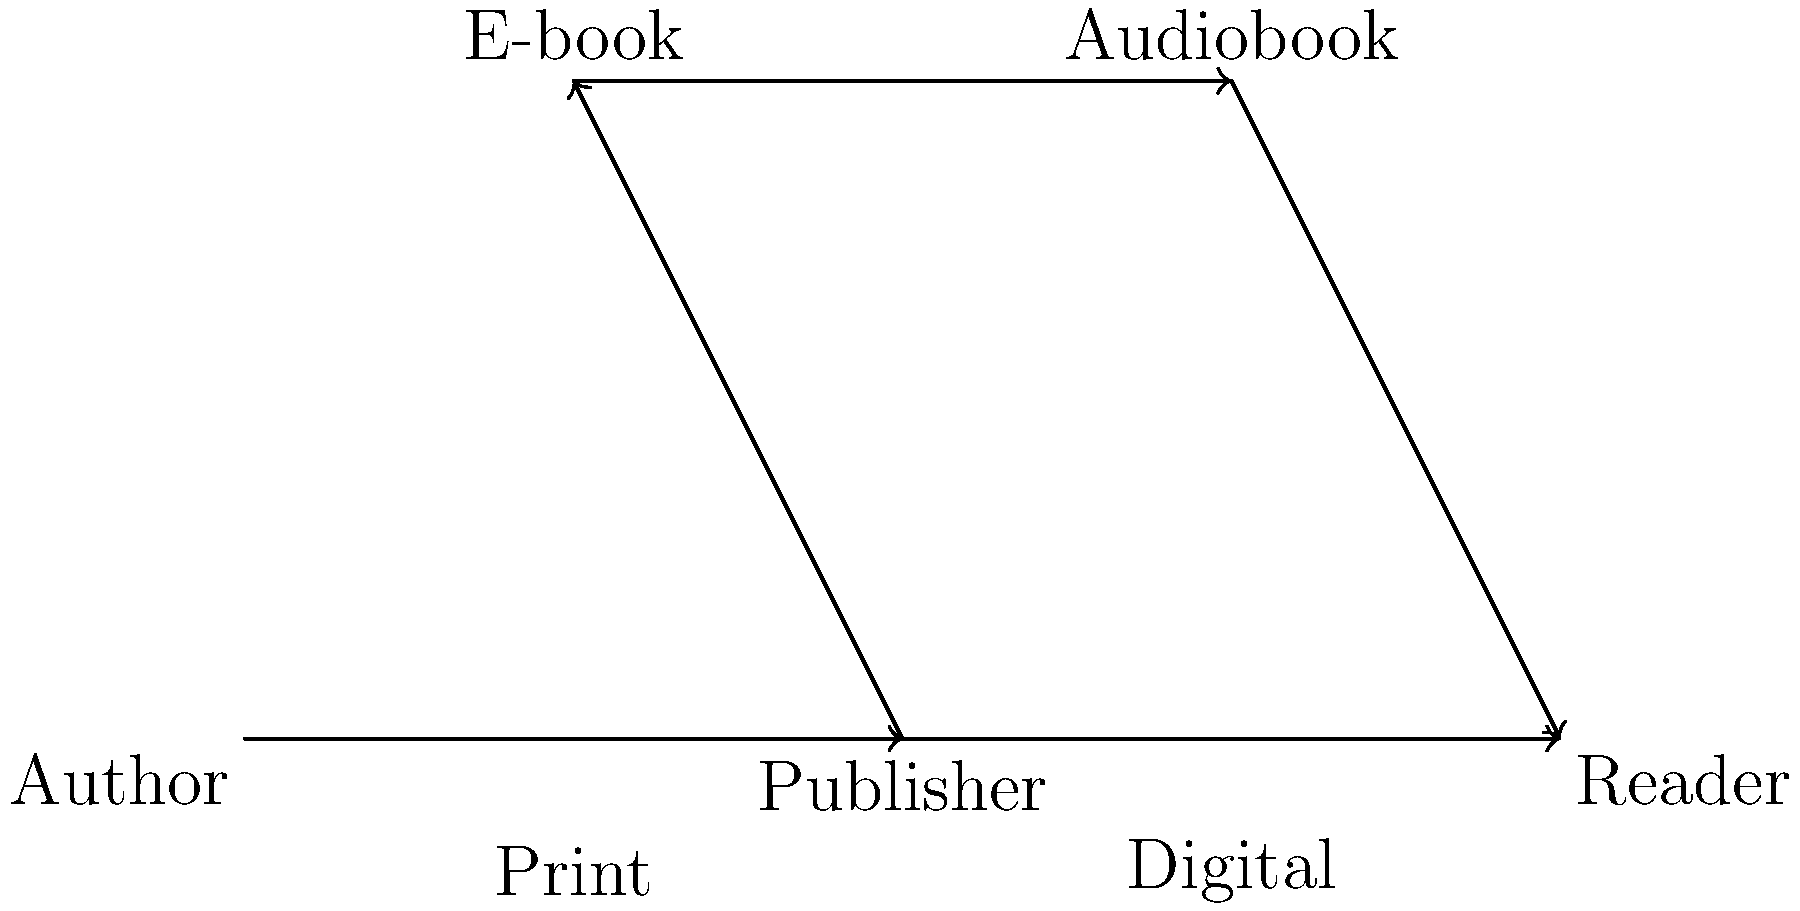In the vector representation of a book's journey from author to reader, which distribution channel typically involves the least amount of physical transportation? To answer this question, let's analyze the different distribution channels shown in the vector diagram:

1. Print books (bottom path):
   - Involves physical printing of books
   - Requires transportation from publisher to bookstores or directly to readers
   - Highest amount of physical transportation

2. E-books (upper-left path):
   - Digital files transmitted electronically
   - No physical product to transport
   - Minimal physical transportation (only for the devices used to read e-books)

3. Audiobooks (upper-right path):
   - Digital audio files transmitted electronically
   - No physical product to transport
   - Minimal physical transportation (only for the devices used to listen to audiobooks)

Comparing these channels, we can see that both e-books and audiobooks involve significantly less physical transportation than print books. However, e-books typically require less data transfer and storage space compared to audiobooks, making them slightly more efficient in terms of digital distribution.

Therefore, the distribution channel that typically involves the least amount of physical transportation is the e-book channel.
Answer: E-books 